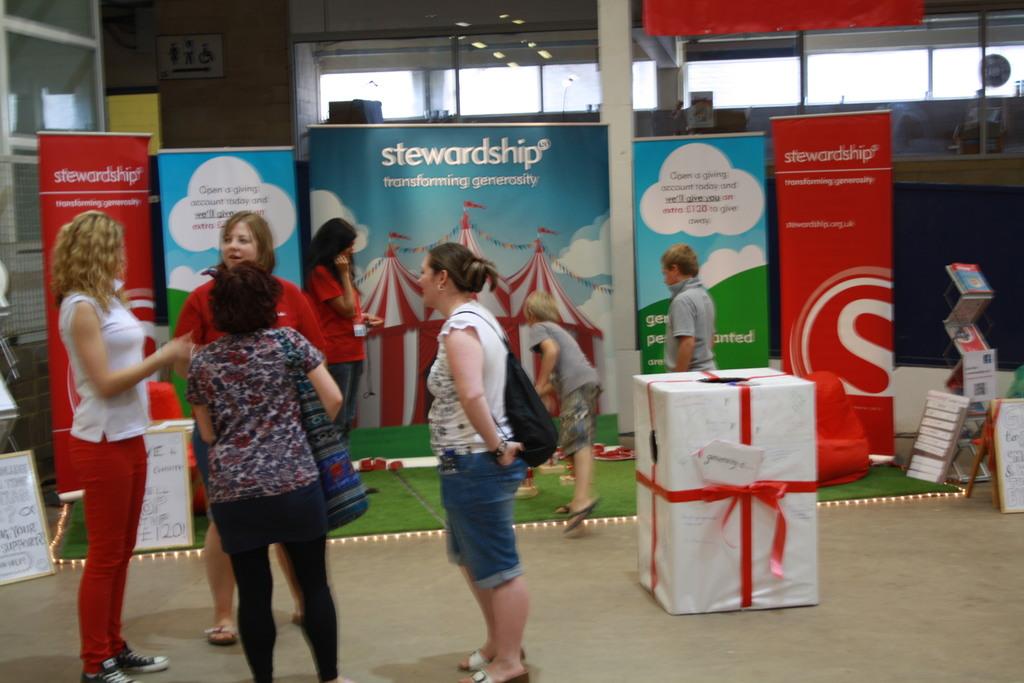What is the name of the company with the booth?
Make the answer very short. Stewardship. Can you tell what does the cloud say?
Offer a very short reply. Unanswerable. 